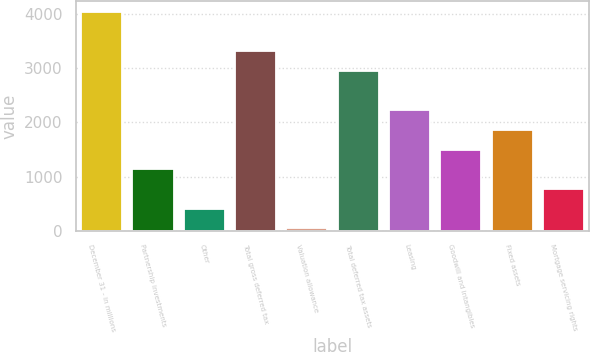Convert chart to OTSL. <chart><loc_0><loc_0><loc_500><loc_500><bar_chart><fcel>December 31 - in millions<fcel>Partnership investments<fcel>Other<fcel>Total gross deferred tax<fcel>Valuation allowance<fcel>Total deferred tax assets<fcel>Leasing<fcel>Goodwill and intangibles<fcel>Fixed assets<fcel>Mortgage servicing rights<nl><fcel>4040.7<fcel>1131.1<fcel>403.7<fcel>3313.3<fcel>40<fcel>2949.6<fcel>2222.2<fcel>1494.8<fcel>1858.5<fcel>767.4<nl></chart> 